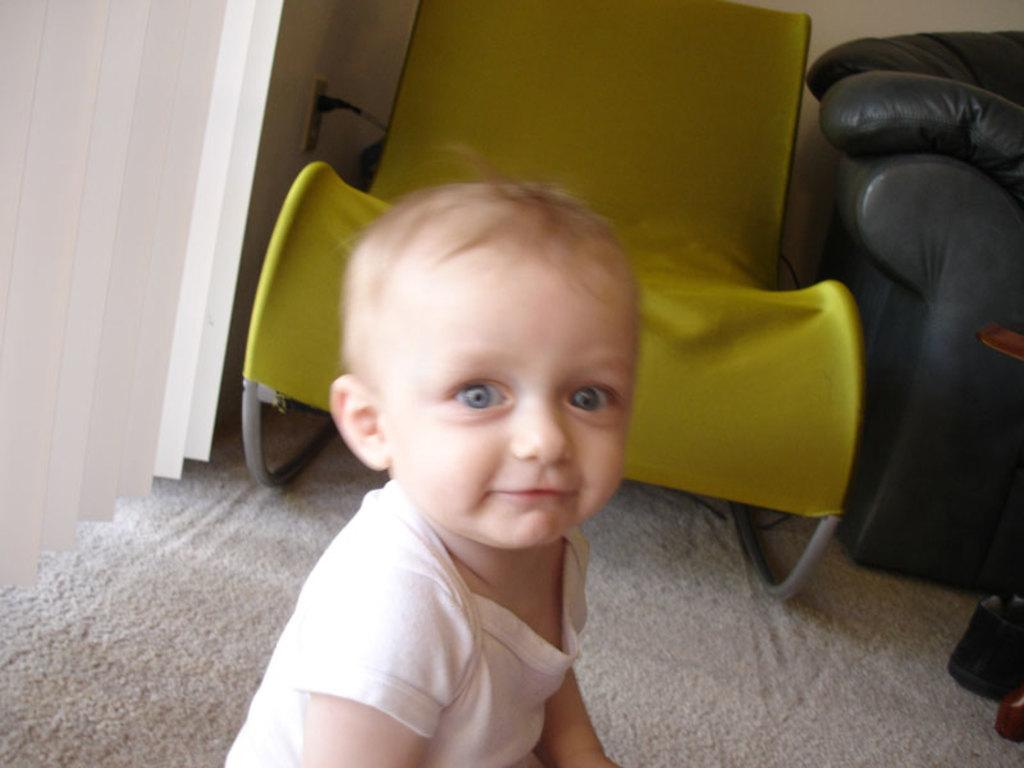What is the main subject of the image? There is a baby in the image. What is the baby wearing? The baby is wearing clothes. What is the baby's expression in the image? The baby is smiling. What type of furniture is present in the image? There is a couch and a rest chair in the image. What part of the room can be seen in the image? The floor is visible in the image. What type of window treatment is present in the image? There are window blinds in the image. Can you tell me how many goldfish are swimming in the baby's pocket in the image? There are no goldfish present in the image, and the baby is not shown wearing any pockets. 